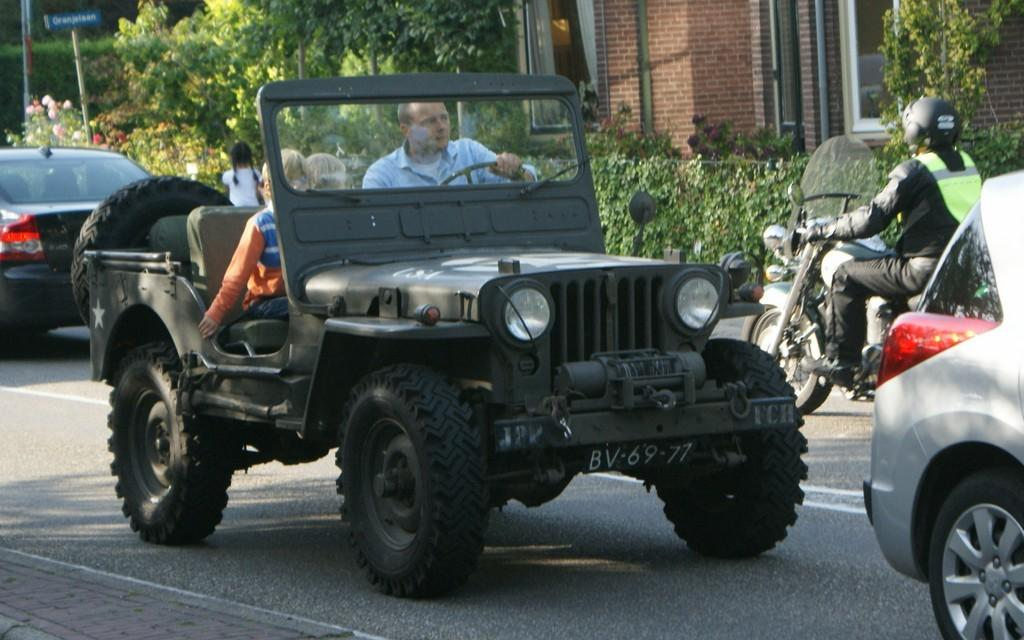What type of vehicles are present in the image? There is a car and a motorbike in the image. What are the vehicles doing in the image? Both the car and motorbike are moving on the road. What can be seen in the background of the image? There is a building and trees in the background of the image. How many pets are visible in the image? There are no pets present in the image. What type of cable can be seen connecting the car and motorbike in the image? There is no cable connecting the car and motorbike in the image. 